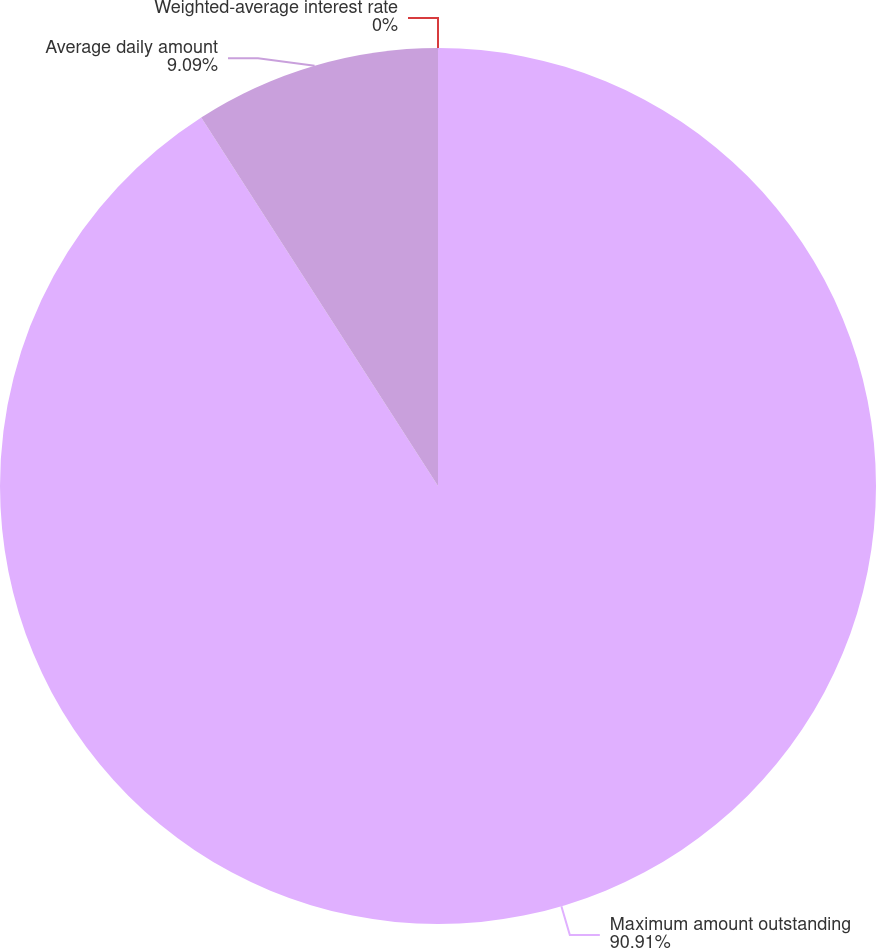<chart> <loc_0><loc_0><loc_500><loc_500><pie_chart><fcel>Maximum amount outstanding<fcel>Average daily amount<fcel>Weighted-average interest rate<nl><fcel>90.91%<fcel>9.09%<fcel>0.0%<nl></chart> 